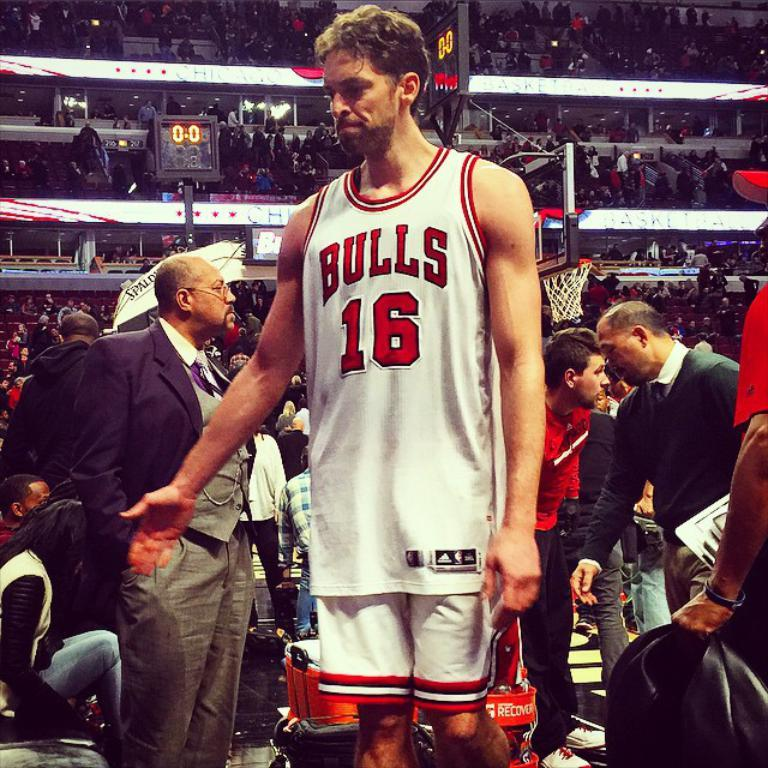<image>
Describe the image concisely. a man that is wearing a Bulls jersey 